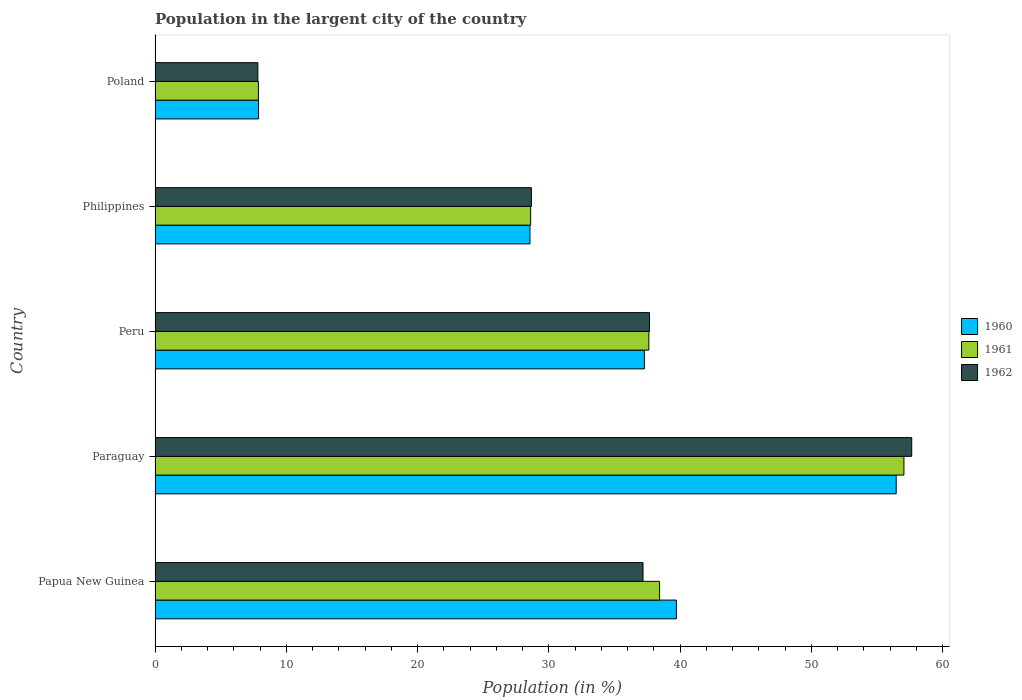How many groups of bars are there?
Offer a very short reply. 5. Are the number of bars on each tick of the Y-axis equal?
Keep it short and to the point. Yes. How many bars are there on the 2nd tick from the bottom?
Ensure brevity in your answer.  3. In how many cases, is the number of bars for a given country not equal to the number of legend labels?
Your answer should be compact. 0. What is the percentage of population in the largent city in 1960 in Peru?
Offer a very short reply. 37.28. Across all countries, what is the maximum percentage of population in the largent city in 1962?
Your answer should be very brief. 57.65. Across all countries, what is the minimum percentage of population in the largent city in 1961?
Your answer should be compact. 7.88. In which country was the percentage of population in the largent city in 1962 maximum?
Your answer should be compact. Paraguay. In which country was the percentage of population in the largent city in 1962 minimum?
Keep it short and to the point. Poland. What is the total percentage of population in the largent city in 1960 in the graph?
Ensure brevity in your answer.  169.92. What is the difference between the percentage of population in the largent city in 1960 in Peru and that in Philippines?
Offer a very short reply. 8.72. What is the difference between the percentage of population in the largent city in 1960 in Peru and the percentage of population in the largent city in 1962 in Philippines?
Give a very brief answer. 8.61. What is the average percentage of population in the largent city in 1962 per country?
Your answer should be very brief. 33.8. What is the difference between the percentage of population in the largent city in 1960 and percentage of population in the largent city in 1961 in Poland?
Make the answer very short. 0.01. What is the ratio of the percentage of population in the largent city in 1962 in Paraguay to that in Philippines?
Keep it short and to the point. 2.01. Is the difference between the percentage of population in the largent city in 1960 in Paraguay and Poland greater than the difference between the percentage of population in the largent city in 1961 in Paraguay and Poland?
Make the answer very short. No. What is the difference between the highest and the second highest percentage of population in the largent city in 1960?
Provide a short and direct response. 16.75. What is the difference between the highest and the lowest percentage of population in the largent city in 1961?
Ensure brevity in your answer.  49.18. What does the 3rd bar from the bottom in Papua New Guinea represents?
Your answer should be very brief. 1962. Is it the case that in every country, the sum of the percentage of population in the largent city in 1960 and percentage of population in the largent city in 1962 is greater than the percentage of population in the largent city in 1961?
Give a very brief answer. Yes. How many bars are there?
Keep it short and to the point. 15. Are all the bars in the graph horizontal?
Your response must be concise. Yes. Does the graph contain grids?
Provide a short and direct response. No. Where does the legend appear in the graph?
Offer a terse response. Center right. How many legend labels are there?
Your answer should be very brief. 3. How are the legend labels stacked?
Your answer should be compact. Vertical. What is the title of the graph?
Offer a terse response. Population in the largent city of the country. What is the label or title of the X-axis?
Give a very brief answer. Population (in %). What is the Population (in %) of 1960 in Papua New Guinea?
Your answer should be very brief. 39.72. What is the Population (in %) of 1961 in Papua New Guinea?
Keep it short and to the point. 38.44. What is the Population (in %) of 1962 in Papua New Guinea?
Keep it short and to the point. 37.18. What is the Population (in %) of 1960 in Paraguay?
Offer a terse response. 56.47. What is the Population (in %) of 1961 in Paraguay?
Make the answer very short. 57.06. What is the Population (in %) in 1962 in Paraguay?
Give a very brief answer. 57.65. What is the Population (in %) in 1960 in Peru?
Your answer should be compact. 37.28. What is the Population (in %) in 1961 in Peru?
Your answer should be very brief. 37.62. What is the Population (in %) of 1962 in Peru?
Ensure brevity in your answer.  37.67. What is the Population (in %) in 1960 in Philippines?
Provide a succinct answer. 28.56. What is the Population (in %) of 1961 in Philippines?
Offer a very short reply. 28.62. What is the Population (in %) in 1962 in Philippines?
Your response must be concise. 28.67. What is the Population (in %) in 1960 in Poland?
Provide a succinct answer. 7.88. What is the Population (in %) of 1961 in Poland?
Your answer should be compact. 7.88. What is the Population (in %) in 1962 in Poland?
Provide a short and direct response. 7.83. Across all countries, what is the maximum Population (in %) of 1960?
Offer a terse response. 56.47. Across all countries, what is the maximum Population (in %) of 1961?
Your answer should be very brief. 57.06. Across all countries, what is the maximum Population (in %) in 1962?
Make the answer very short. 57.65. Across all countries, what is the minimum Population (in %) of 1960?
Your answer should be compact. 7.88. Across all countries, what is the minimum Population (in %) of 1961?
Your answer should be very brief. 7.88. Across all countries, what is the minimum Population (in %) of 1962?
Your answer should be very brief. 7.83. What is the total Population (in %) in 1960 in the graph?
Your response must be concise. 169.92. What is the total Population (in %) in 1961 in the graph?
Your response must be concise. 169.61. What is the total Population (in %) in 1962 in the graph?
Your answer should be compact. 169.01. What is the difference between the Population (in %) of 1960 in Papua New Guinea and that in Paraguay?
Your answer should be compact. -16.75. What is the difference between the Population (in %) of 1961 in Papua New Guinea and that in Paraguay?
Your answer should be very brief. -18.62. What is the difference between the Population (in %) in 1962 in Papua New Guinea and that in Paraguay?
Your response must be concise. -20.47. What is the difference between the Population (in %) in 1960 in Papua New Guinea and that in Peru?
Provide a succinct answer. 2.44. What is the difference between the Population (in %) of 1961 in Papua New Guinea and that in Peru?
Provide a succinct answer. 0.82. What is the difference between the Population (in %) of 1962 in Papua New Guinea and that in Peru?
Your answer should be very brief. -0.5. What is the difference between the Population (in %) in 1960 in Papua New Guinea and that in Philippines?
Make the answer very short. 11.16. What is the difference between the Population (in %) in 1961 in Papua New Guinea and that in Philippines?
Offer a terse response. 9.82. What is the difference between the Population (in %) in 1962 in Papua New Guinea and that in Philippines?
Your response must be concise. 8.5. What is the difference between the Population (in %) in 1960 in Papua New Guinea and that in Poland?
Your answer should be compact. 31.84. What is the difference between the Population (in %) of 1961 in Papua New Guinea and that in Poland?
Offer a very short reply. 30.57. What is the difference between the Population (in %) of 1962 in Papua New Guinea and that in Poland?
Your answer should be compact. 29.35. What is the difference between the Population (in %) of 1960 in Paraguay and that in Peru?
Keep it short and to the point. 19.19. What is the difference between the Population (in %) in 1961 in Paraguay and that in Peru?
Provide a short and direct response. 19.44. What is the difference between the Population (in %) of 1962 in Paraguay and that in Peru?
Give a very brief answer. 19.98. What is the difference between the Population (in %) in 1960 in Paraguay and that in Philippines?
Make the answer very short. 27.9. What is the difference between the Population (in %) in 1961 in Paraguay and that in Philippines?
Offer a very short reply. 28.44. What is the difference between the Population (in %) of 1962 in Paraguay and that in Philippines?
Your answer should be compact. 28.98. What is the difference between the Population (in %) of 1960 in Paraguay and that in Poland?
Give a very brief answer. 48.58. What is the difference between the Population (in %) in 1961 in Paraguay and that in Poland?
Give a very brief answer. 49.18. What is the difference between the Population (in %) of 1962 in Paraguay and that in Poland?
Offer a terse response. 49.82. What is the difference between the Population (in %) of 1960 in Peru and that in Philippines?
Provide a succinct answer. 8.72. What is the difference between the Population (in %) in 1961 in Peru and that in Philippines?
Your answer should be compact. 9.01. What is the difference between the Population (in %) of 1962 in Peru and that in Philippines?
Your response must be concise. 9. What is the difference between the Population (in %) in 1960 in Peru and that in Poland?
Your answer should be very brief. 29.4. What is the difference between the Population (in %) of 1961 in Peru and that in Poland?
Offer a very short reply. 29.75. What is the difference between the Population (in %) in 1962 in Peru and that in Poland?
Your response must be concise. 29.84. What is the difference between the Population (in %) of 1960 in Philippines and that in Poland?
Your response must be concise. 20.68. What is the difference between the Population (in %) of 1961 in Philippines and that in Poland?
Offer a terse response. 20.74. What is the difference between the Population (in %) in 1962 in Philippines and that in Poland?
Provide a short and direct response. 20.84. What is the difference between the Population (in %) in 1960 in Papua New Guinea and the Population (in %) in 1961 in Paraguay?
Your response must be concise. -17.34. What is the difference between the Population (in %) in 1960 in Papua New Guinea and the Population (in %) in 1962 in Paraguay?
Provide a succinct answer. -17.93. What is the difference between the Population (in %) in 1961 in Papua New Guinea and the Population (in %) in 1962 in Paraguay?
Provide a short and direct response. -19.21. What is the difference between the Population (in %) of 1960 in Papua New Guinea and the Population (in %) of 1961 in Peru?
Offer a very short reply. 2.1. What is the difference between the Population (in %) in 1960 in Papua New Guinea and the Population (in %) in 1962 in Peru?
Ensure brevity in your answer.  2.05. What is the difference between the Population (in %) of 1961 in Papua New Guinea and the Population (in %) of 1962 in Peru?
Make the answer very short. 0.77. What is the difference between the Population (in %) of 1960 in Papua New Guinea and the Population (in %) of 1961 in Philippines?
Provide a short and direct response. 11.1. What is the difference between the Population (in %) in 1960 in Papua New Guinea and the Population (in %) in 1962 in Philippines?
Provide a succinct answer. 11.05. What is the difference between the Population (in %) in 1961 in Papua New Guinea and the Population (in %) in 1962 in Philippines?
Your answer should be very brief. 9.77. What is the difference between the Population (in %) of 1960 in Papua New Guinea and the Population (in %) of 1961 in Poland?
Provide a succinct answer. 31.85. What is the difference between the Population (in %) in 1960 in Papua New Guinea and the Population (in %) in 1962 in Poland?
Offer a very short reply. 31.89. What is the difference between the Population (in %) of 1961 in Papua New Guinea and the Population (in %) of 1962 in Poland?
Ensure brevity in your answer.  30.61. What is the difference between the Population (in %) of 1960 in Paraguay and the Population (in %) of 1961 in Peru?
Your answer should be compact. 18.85. What is the difference between the Population (in %) in 1960 in Paraguay and the Population (in %) in 1962 in Peru?
Your answer should be compact. 18.79. What is the difference between the Population (in %) in 1961 in Paraguay and the Population (in %) in 1962 in Peru?
Your response must be concise. 19.38. What is the difference between the Population (in %) of 1960 in Paraguay and the Population (in %) of 1961 in Philippines?
Ensure brevity in your answer.  27.85. What is the difference between the Population (in %) of 1960 in Paraguay and the Population (in %) of 1962 in Philippines?
Offer a very short reply. 27.79. What is the difference between the Population (in %) in 1961 in Paraguay and the Population (in %) in 1962 in Philippines?
Your response must be concise. 28.38. What is the difference between the Population (in %) of 1960 in Paraguay and the Population (in %) of 1961 in Poland?
Offer a very short reply. 48.59. What is the difference between the Population (in %) of 1960 in Paraguay and the Population (in %) of 1962 in Poland?
Offer a terse response. 48.64. What is the difference between the Population (in %) in 1961 in Paraguay and the Population (in %) in 1962 in Poland?
Give a very brief answer. 49.23. What is the difference between the Population (in %) in 1960 in Peru and the Population (in %) in 1961 in Philippines?
Offer a very short reply. 8.67. What is the difference between the Population (in %) of 1960 in Peru and the Population (in %) of 1962 in Philippines?
Provide a succinct answer. 8.61. What is the difference between the Population (in %) of 1961 in Peru and the Population (in %) of 1962 in Philippines?
Give a very brief answer. 8.95. What is the difference between the Population (in %) of 1960 in Peru and the Population (in %) of 1961 in Poland?
Your answer should be compact. 29.41. What is the difference between the Population (in %) of 1960 in Peru and the Population (in %) of 1962 in Poland?
Your answer should be compact. 29.45. What is the difference between the Population (in %) in 1961 in Peru and the Population (in %) in 1962 in Poland?
Offer a terse response. 29.79. What is the difference between the Population (in %) in 1960 in Philippines and the Population (in %) in 1961 in Poland?
Your answer should be very brief. 20.69. What is the difference between the Population (in %) in 1960 in Philippines and the Population (in %) in 1962 in Poland?
Make the answer very short. 20.73. What is the difference between the Population (in %) of 1961 in Philippines and the Population (in %) of 1962 in Poland?
Provide a succinct answer. 20.78. What is the average Population (in %) in 1960 per country?
Your response must be concise. 33.98. What is the average Population (in %) of 1961 per country?
Your answer should be compact. 33.92. What is the average Population (in %) in 1962 per country?
Keep it short and to the point. 33.8. What is the difference between the Population (in %) of 1960 and Population (in %) of 1961 in Papua New Guinea?
Offer a very short reply. 1.28. What is the difference between the Population (in %) in 1960 and Population (in %) in 1962 in Papua New Guinea?
Offer a very short reply. 2.54. What is the difference between the Population (in %) of 1961 and Population (in %) of 1962 in Papua New Guinea?
Your answer should be compact. 1.26. What is the difference between the Population (in %) in 1960 and Population (in %) in 1961 in Paraguay?
Give a very brief answer. -0.59. What is the difference between the Population (in %) in 1960 and Population (in %) in 1962 in Paraguay?
Provide a succinct answer. -1.18. What is the difference between the Population (in %) of 1961 and Population (in %) of 1962 in Paraguay?
Offer a terse response. -0.59. What is the difference between the Population (in %) in 1960 and Population (in %) in 1961 in Peru?
Give a very brief answer. -0.34. What is the difference between the Population (in %) in 1960 and Population (in %) in 1962 in Peru?
Ensure brevity in your answer.  -0.39. What is the difference between the Population (in %) of 1961 and Population (in %) of 1962 in Peru?
Your response must be concise. -0.05. What is the difference between the Population (in %) of 1960 and Population (in %) of 1961 in Philippines?
Provide a short and direct response. -0.05. What is the difference between the Population (in %) in 1960 and Population (in %) in 1962 in Philippines?
Make the answer very short. -0.11. What is the difference between the Population (in %) in 1961 and Population (in %) in 1962 in Philippines?
Provide a succinct answer. -0.06. What is the difference between the Population (in %) in 1960 and Population (in %) in 1961 in Poland?
Provide a short and direct response. 0.01. What is the difference between the Population (in %) in 1960 and Population (in %) in 1962 in Poland?
Your answer should be very brief. 0.05. What is the difference between the Population (in %) in 1961 and Population (in %) in 1962 in Poland?
Your answer should be very brief. 0.04. What is the ratio of the Population (in %) of 1960 in Papua New Guinea to that in Paraguay?
Keep it short and to the point. 0.7. What is the ratio of the Population (in %) of 1961 in Papua New Guinea to that in Paraguay?
Make the answer very short. 0.67. What is the ratio of the Population (in %) in 1962 in Papua New Guinea to that in Paraguay?
Make the answer very short. 0.64. What is the ratio of the Population (in %) of 1960 in Papua New Guinea to that in Peru?
Make the answer very short. 1.07. What is the ratio of the Population (in %) of 1961 in Papua New Guinea to that in Peru?
Provide a succinct answer. 1.02. What is the ratio of the Population (in %) of 1962 in Papua New Guinea to that in Peru?
Keep it short and to the point. 0.99. What is the ratio of the Population (in %) of 1960 in Papua New Guinea to that in Philippines?
Your answer should be compact. 1.39. What is the ratio of the Population (in %) of 1961 in Papua New Guinea to that in Philippines?
Give a very brief answer. 1.34. What is the ratio of the Population (in %) of 1962 in Papua New Guinea to that in Philippines?
Ensure brevity in your answer.  1.3. What is the ratio of the Population (in %) of 1960 in Papua New Guinea to that in Poland?
Your response must be concise. 5.04. What is the ratio of the Population (in %) in 1961 in Papua New Guinea to that in Poland?
Keep it short and to the point. 4.88. What is the ratio of the Population (in %) in 1962 in Papua New Guinea to that in Poland?
Keep it short and to the point. 4.75. What is the ratio of the Population (in %) in 1960 in Paraguay to that in Peru?
Give a very brief answer. 1.51. What is the ratio of the Population (in %) of 1961 in Paraguay to that in Peru?
Give a very brief answer. 1.52. What is the ratio of the Population (in %) in 1962 in Paraguay to that in Peru?
Make the answer very short. 1.53. What is the ratio of the Population (in %) of 1960 in Paraguay to that in Philippines?
Keep it short and to the point. 1.98. What is the ratio of the Population (in %) of 1961 in Paraguay to that in Philippines?
Offer a terse response. 1.99. What is the ratio of the Population (in %) in 1962 in Paraguay to that in Philippines?
Offer a very short reply. 2.01. What is the ratio of the Population (in %) of 1960 in Paraguay to that in Poland?
Keep it short and to the point. 7.16. What is the ratio of the Population (in %) of 1961 in Paraguay to that in Poland?
Provide a succinct answer. 7.25. What is the ratio of the Population (in %) of 1962 in Paraguay to that in Poland?
Keep it short and to the point. 7.36. What is the ratio of the Population (in %) of 1960 in Peru to that in Philippines?
Provide a succinct answer. 1.31. What is the ratio of the Population (in %) of 1961 in Peru to that in Philippines?
Offer a very short reply. 1.31. What is the ratio of the Population (in %) in 1962 in Peru to that in Philippines?
Give a very brief answer. 1.31. What is the ratio of the Population (in %) in 1960 in Peru to that in Poland?
Keep it short and to the point. 4.73. What is the ratio of the Population (in %) of 1961 in Peru to that in Poland?
Provide a short and direct response. 4.78. What is the ratio of the Population (in %) in 1962 in Peru to that in Poland?
Make the answer very short. 4.81. What is the ratio of the Population (in %) in 1960 in Philippines to that in Poland?
Provide a short and direct response. 3.62. What is the ratio of the Population (in %) in 1961 in Philippines to that in Poland?
Your answer should be very brief. 3.63. What is the ratio of the Population (in %) in 1962 in Philippines to that in Poland?
Give a very brief answer. 3.66. What is the difference between the highest and the second highest Population (in %) in 1960?
Your answer should be compact. 16.75. What is the difference between the highest and the second highest Population (in %) of 1961?
Offer a very short reply. 18.62. What is the difference between the highest and the second highest Population (in %) in 1962?
Your answer should be very brief. 19.98. What is the difference between the highest and the lowest Population (in %) in 1960?
Offer a very short reply. 48.58. What is the difference between the highest and the lowest Population (in %) of 1961?
Give a very brief answer. 49.18. What is the difference between the highest and the lowest Population (in %) in 1962?
Keep it short and to the point. 49.82. 